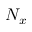Convert formula to latex. <formula><loc_0><loc_0><loc_500><loc_500>N _ { x }</formula> 